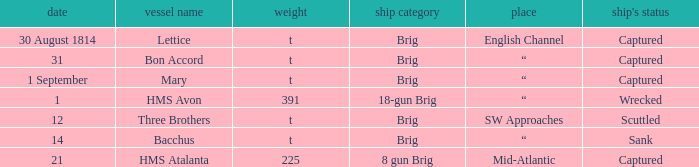For the ship that was a brig and located in the English Channel, what was the disposition of ship? Captured. 